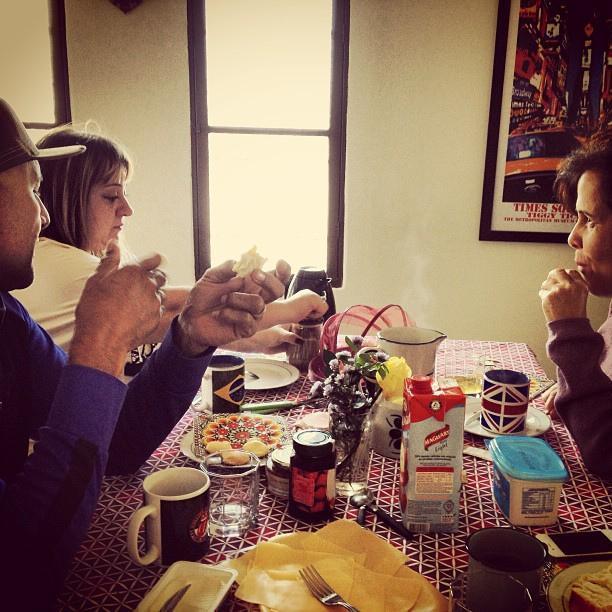How many of the people are female?
Give a very brief answer. 1. How many people?
Give a very brief answer. 3. How many cell phones are visible?
Give a very brief answer. 1. How many people are there?
Give a very brief answer. 3. How many cups are there?
Give a very brief answer. 6. How many chairs are on the right side of the tree?
Give a very brief answer. 0. 